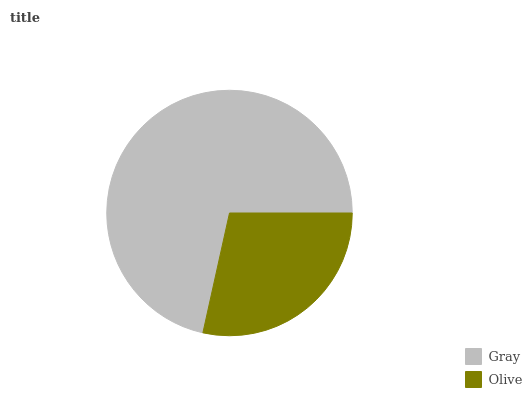Is Olive the minimum?
Answer yes or no. Yes. Is Gray the maximum?
Answer yes or no. Yes. Is Olive the maximum?
Answer yes or no. No. Is Gray greater than Olive?
Answer yes or no. Yes. Is Olive less than Gray?
Answer yes or no. Yes. Is Olive greater than Gray?
Answer yes or no. No. Is Gray less than Olive?
Answer yes or no. No. Is Gray the high median?
Answer yes or no. Yes. Is Olive the low median?
Answer yes or no. Yes. Is Olive the high median?
Answer yes or no. No. Is Gray the low median?
Answer yes or no. No. 